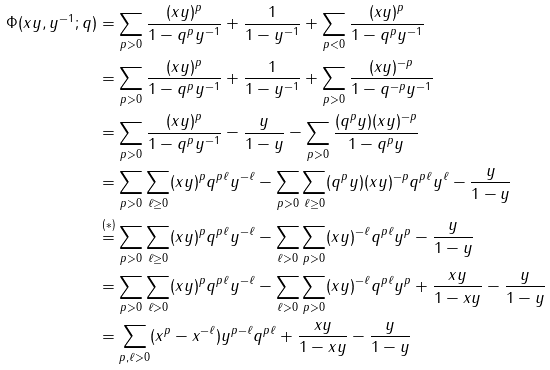Convert formula to latex. <formula><loc_0><loc_0><loc_500><loc_500>\Phi ( x y , y ^ { - 1 } ; q ) & = \sum _ { p > 0 } \frac { ( x y ) ^ { p } } { 1 - q ^ { p } y ^ { - 1 } } + \frac { 1 } { 1 - y ^ { - 1 } } + \sum _ { p < 0 } \frac { ( x y ) ^ { p } } { 1 - q ^ { p } y ^ { - 1 } } \\ & = \sum _ { p > 0 } \frac { ( x y ) ^ { p } } { 1 - q ^ { p } y ^ { - 1 } } + \frac { 1 } { 1 - y ^ { - 1 } } + \sum _ { p > 0 } \frac { ( x y ) ^ { - p } } { 1 - q ^ { - p } y ^ { - 1 } } \\ & = \sum _ { p > 0 } \frac { ( x y ) ^ { p } } { 1 - q ^ { p } y ^ { - 1 } } - \frac { y } { 1 - y } - \sum _ { p > 0 } \frac { ( q ^ { p } y ) ( x y ) ^ { - p } } { 1 - q ^ { p } y } \\ & = \sum _ { p > 0 } \sum _ { \ell \geq 0 } ( x y ) ^ { p } q ^ { p \ell } y ^ { - \ell } - \sum _ { p > 0 } \sum _ { \ell \geq 0 } ( q ^ { p } y ) ( x y ) ^ { - p } q ^ { p \ell } y ^ { \ell } - \frac { y } { 1 - y } \\ & \stackrel { ( * ) } { = } \sum _ { p > 0 } \sum _ { \ell \geq 0 } ( x y ) ^ { p } q ^ { p \ell } y ^ { - \ell } - \sum _ { \ell > 0 } \sum _ { p > 0 } ( x y ) ^ { - \ell } q ^ { p \ell } y ^ { p } - \frac { y } { 1 - y } \\ & = \sum _ { p > 0 } \sum _ { \ell > 0 } ( x y ) ^ { p } q ^ { p \ell } y ^ { - \ell } - \sum _ { \ell > 0 } \sum _ { p > 0 } ( x y ) ^ { - \ell } q ^ { p \ell } y ^ { p } + \frac { x y } { 1 - x y } - \frac { y } { 1 - y } \\ & = \sum _ { p , \ell > 0 } ( x ^ { p } - x ^ { - \ell } ) y ^ { p - \ell } q ^ { p \ell } + \frac { x y } { 1 - x y } - \frac { y } { 1 - y } \\</formula> 